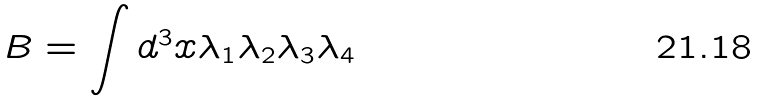<formula> <loc_0><loc_0><loc_500><loc_500>B = \int d ^ { 3 } x \lambda _ { 1 } \lambda _ { 2 } \lambda _ { 3 } \lambda _ { 4 }</formula> 